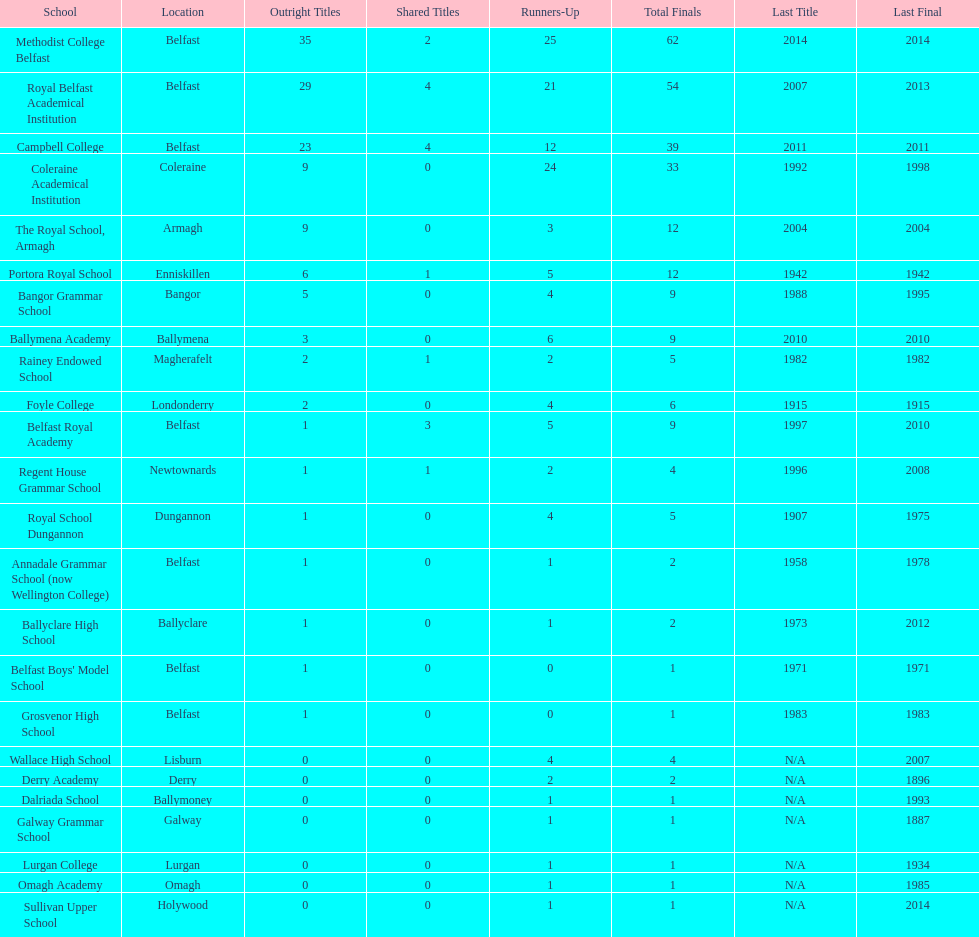What is the difference in runners-up from coleraine academical institution and royal school dungannon? 20. 